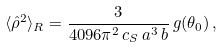Convert formula to latex. <formula><loc_0><loc_0><loc_500><loc_500>\langle \hat { \rho } ^ { 2 } \rangle _ { R } = \frac { 3 } { 4 0 9 6 \pi ^ { 2 } \, c _ { S } \, a ^ { 3 } \, b } \, g ( \theta _ { 0 } ) \, ,</formula> 